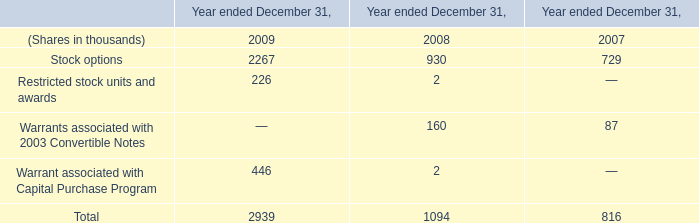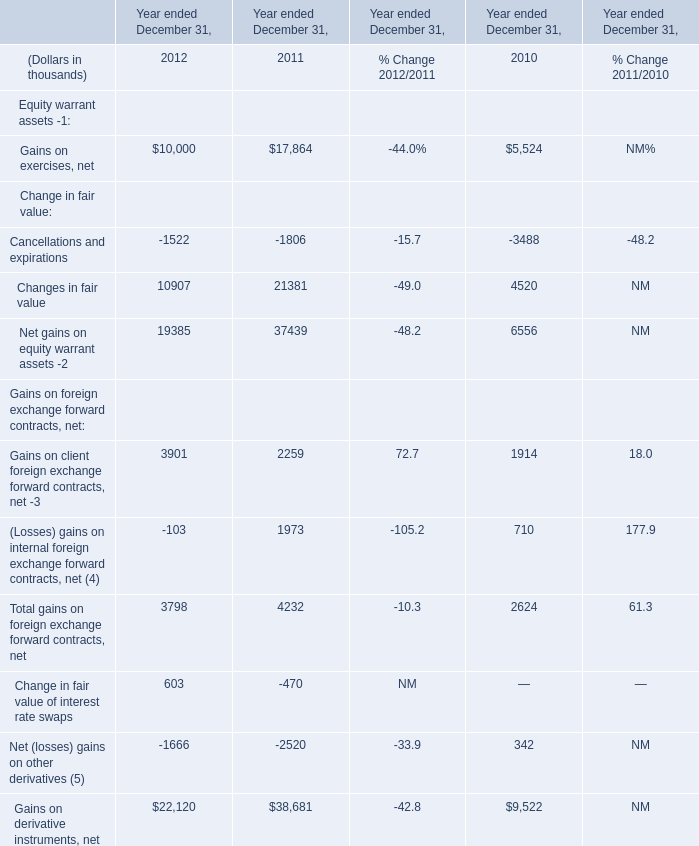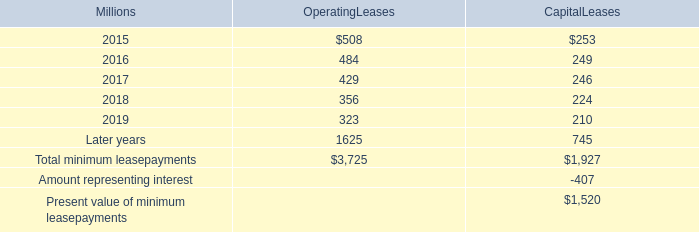Which year is Changes in fair value the most? 
Answer: 2011. 